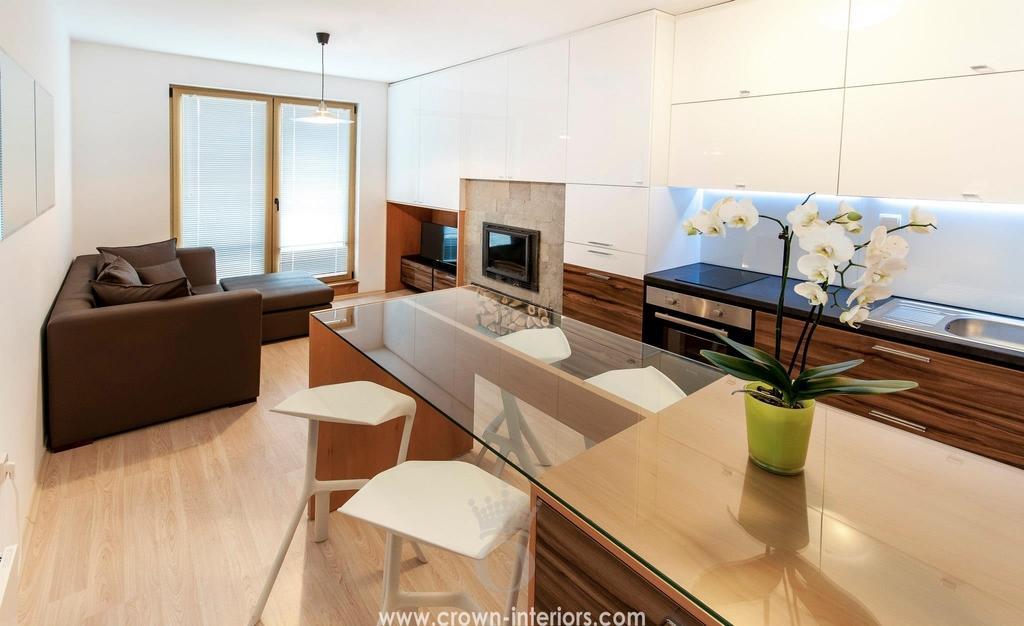In one or two sentences, can you explain what this image depicts? In this image I can see a room. In this room there is a flower vase on the table,couch,countertop,sink and the door. 